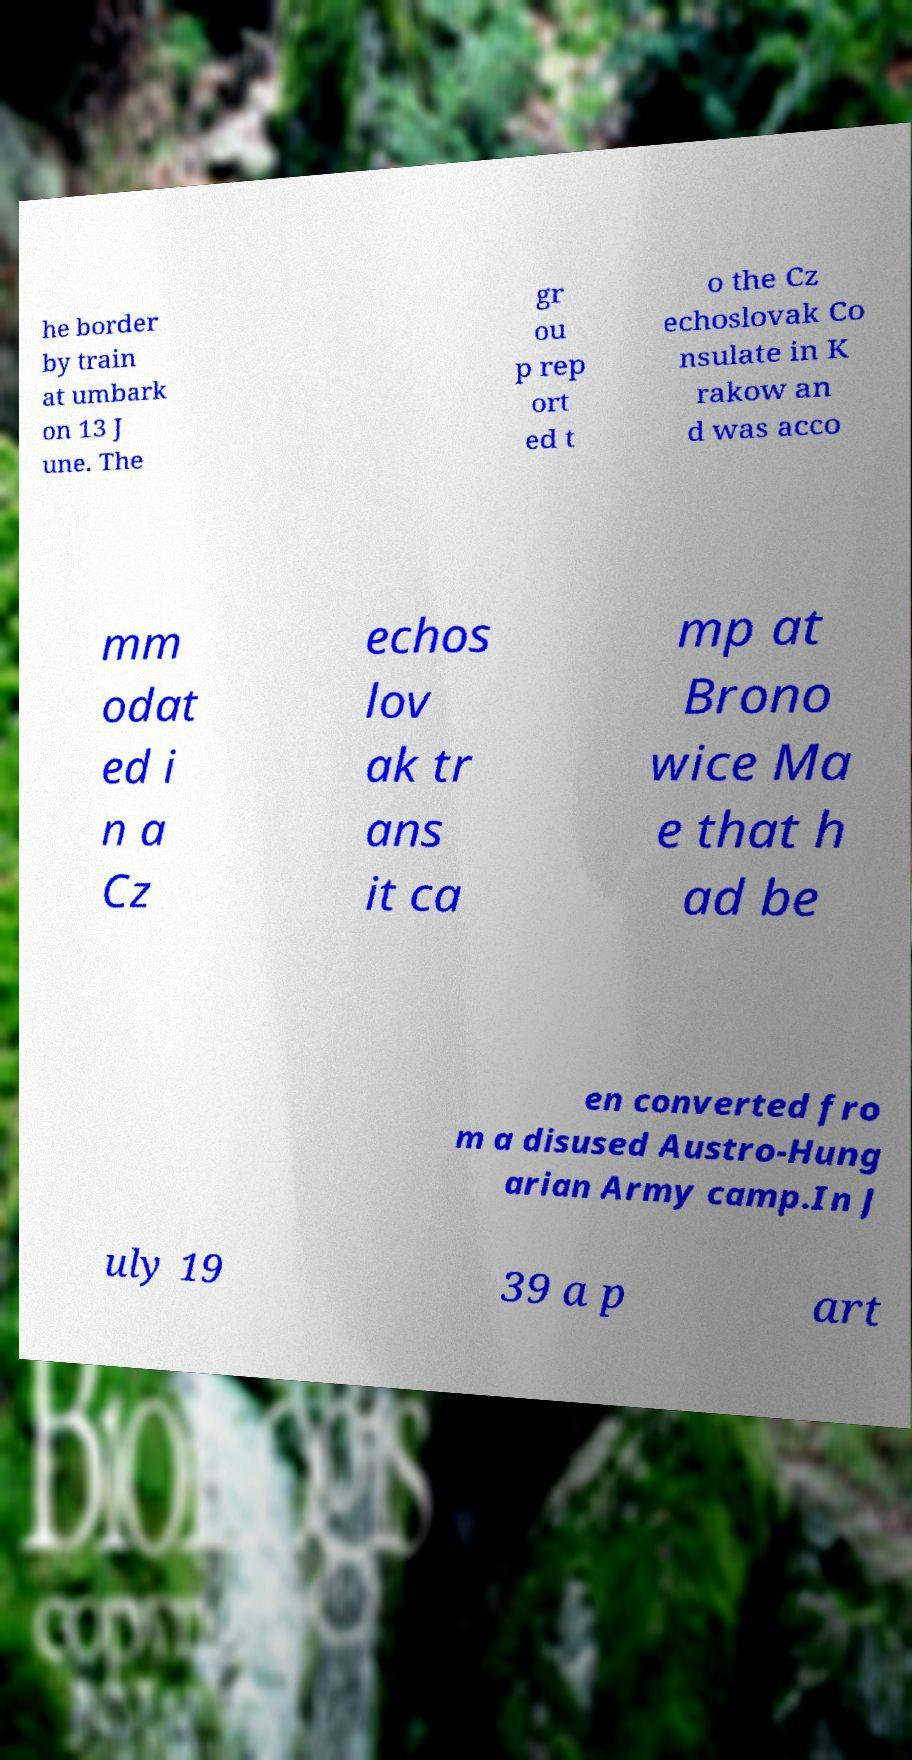Please identify and transcribe the text found in this image. he border by train at umbark on 13 J une. The gr ou p rep ort ed t o the Cz echoslovak Co nsulate in K rakow an d was acco mm odat ed i n a Cz echos lov ak tr ans it ca mp at Brono wice Ma e that h ad be en converted fro m a disused Austro-Hung arian Army camp.In J uly 19 39 a p art 